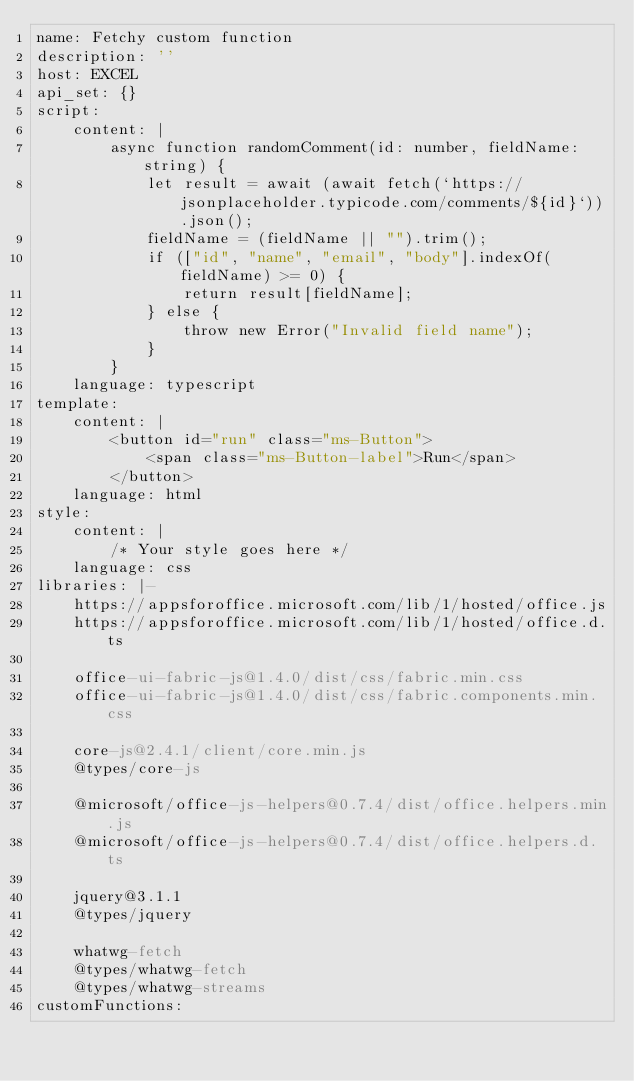Convert code to text. <code><loc_0><loc_0><loc_500><loc_500><_YAML_>name: Fetchy custom function
description: ''
host: EXCEL
api_set: {}
script:
    content: |
        async function randomComment(id: number, fieldName: string) {
            let result = await (await fetch(`https://jsonplaceholder.typicode.com/comments/${id}`)).json();
            fieldName = (fieldName || "").trim();
            if (["id", "name", "email", "body"].indexOf(fieldName) >= 0) {
                return result[fieldName];
            } else {
                throw new Error("Invalid field name");
            }
        }
    language: typescript
template:
    content: |
        <button id="run" class="ms-Button">
            <span class="ms-Button-label">Run</span>
        </button>
    language: html
style:
    content: |
        /* Your style goes here */
    language: css
libraries: |-
    https://appsforoffice.microsoft.com/lib/1/hosted/office.js
    https://appsforoffice.microsoft.com/lib/1/hosted/office.d.ts

    office-ui-fabric-js@1.4.0/dist/css/fabric.min.css
    office-ui-fabric-js@1.4.0/dist/css/fabric.components.min.css

    core-js@2.4.1/client/core.min.js
    @types/core-js

    @microsoft/office-js-helpers@0.7.4/dist/office.helpers.min.js
    @microsoft/office-js-helpers@0.7.4/dist/office.helpers.d.ts

    jquery@3.1.1
    @types/jquery

    whatwg-fetch
    @types/whatwg-fetch
    @types/whatwg-streams
customFunctions:</code> 